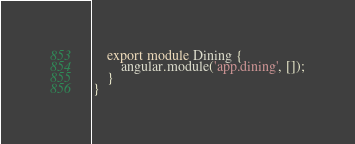Convert code to text. <code><loc_0><loc_0><loc_500><loc_500><_TypeScript_>    export module Dining {
        angular.module('app.dining', []);
    }
}
</code> 